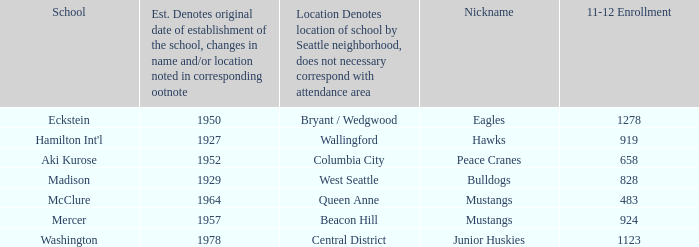What is the geographical location of eckstein school? Bryant / Wedgwood. 